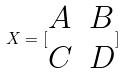Convert formula to latex. <formula><loc_0><loc_0><loc_500><loc_500>X = [ \begin{matrix} A & B \\ C & D \end{matrix} ]</formula> 